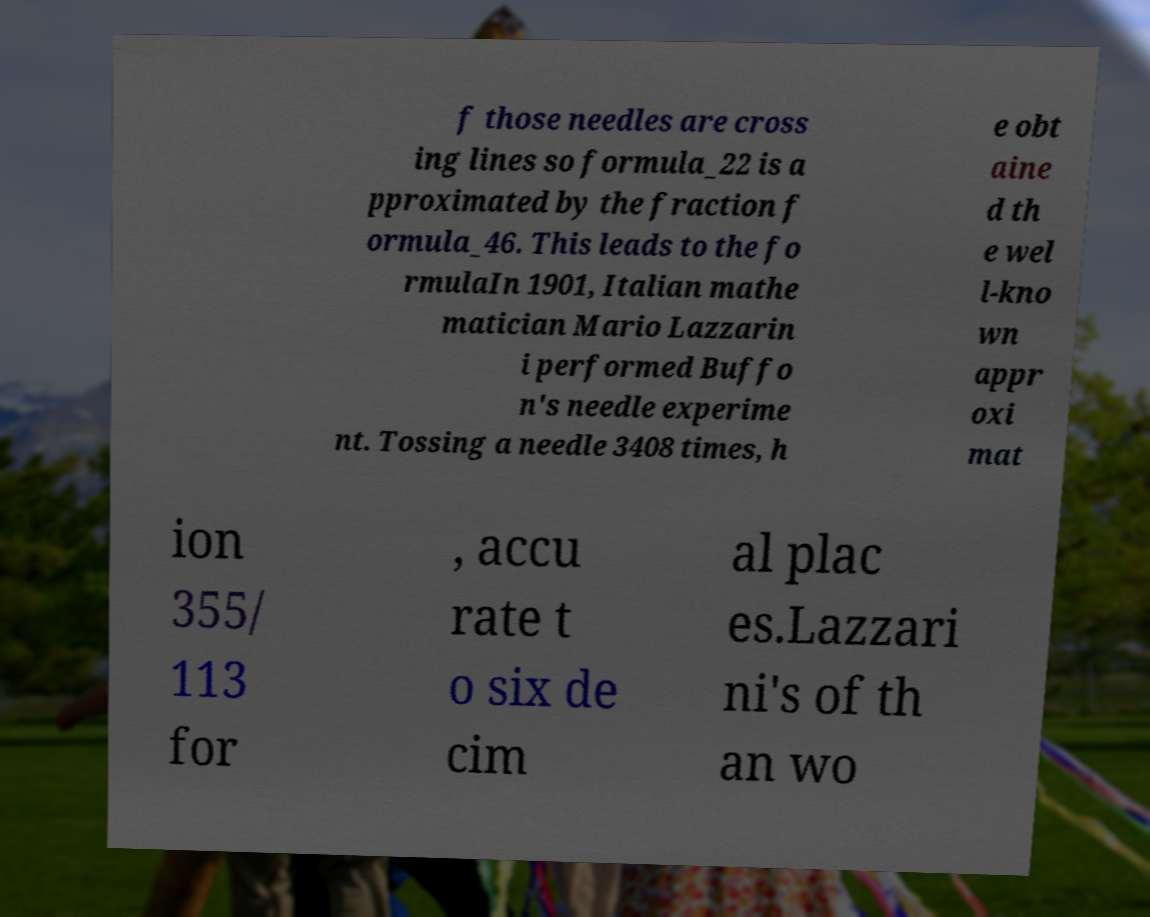Can you accurately transcribe the text from the provided image for me? f those needles are cross ing lines so formula_22 is a pproximated by the fraction f ormula_46. This leads to the fo rmulaIn 1901, Italian mathe matician Mario Lazzarin i performed Buffo n's needle experime nt. Tossing a needle 3408 times, h e obt aine d th e wel l-kno wn appr oxi mat ion 355/ 113 for , accu rate t o six de cim al plac es.Lazzari ni's of th an wo 